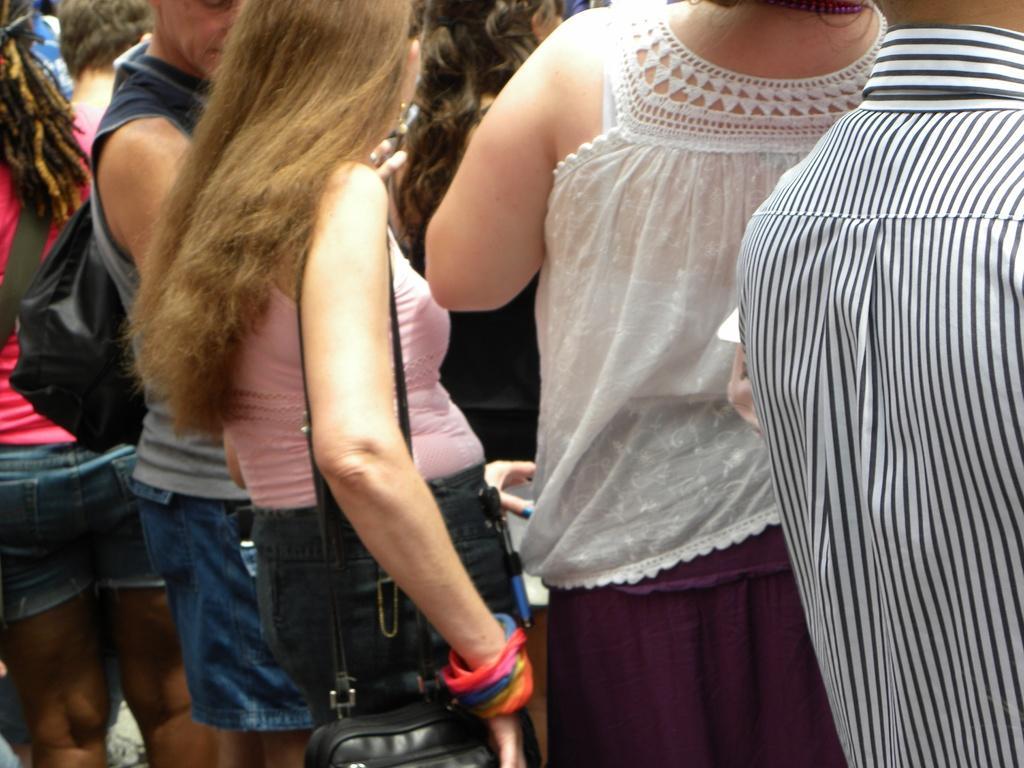Can you describe this image briefly? In this image, we can see a group of people are standing. Few are wearing bags. Here a woman is holding some object. 